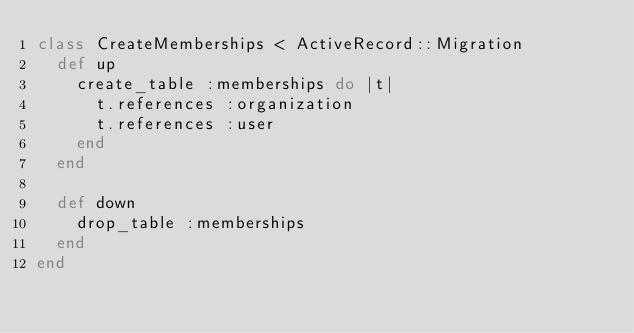<code> <loc_0><loc_0><loc_500><loc_500><_Ruby_>class CreateMemberships < ActiveRecord::Migration
  def up
    create_table :memberships do |t|
      t.references :organization
      t.references :user
    end
  end

  def down
    drop_table :memberships
  end
end
</code> 